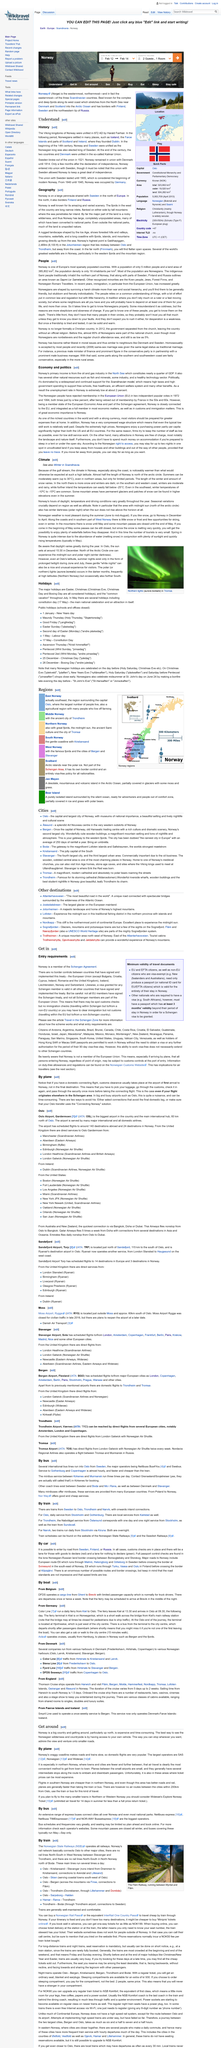Indicate a few pertinent items in this graphic. The oil and gas industry plays a significant role in Norway's economy, contributing nearly a quarter of the country's Gross Domestic Product (GDP). Winter is darker in the North than in the South. Norway is located in Scandinavia. According to data, Norway's economy and politics are estimated to be around 2% and 5% respectively. In 1972 and 1994, Norway's politics were voted out by a minority of the population with less than 10% of the vote. Norway's primary source of income is derived from the oil and gas industry in the North Sea. 